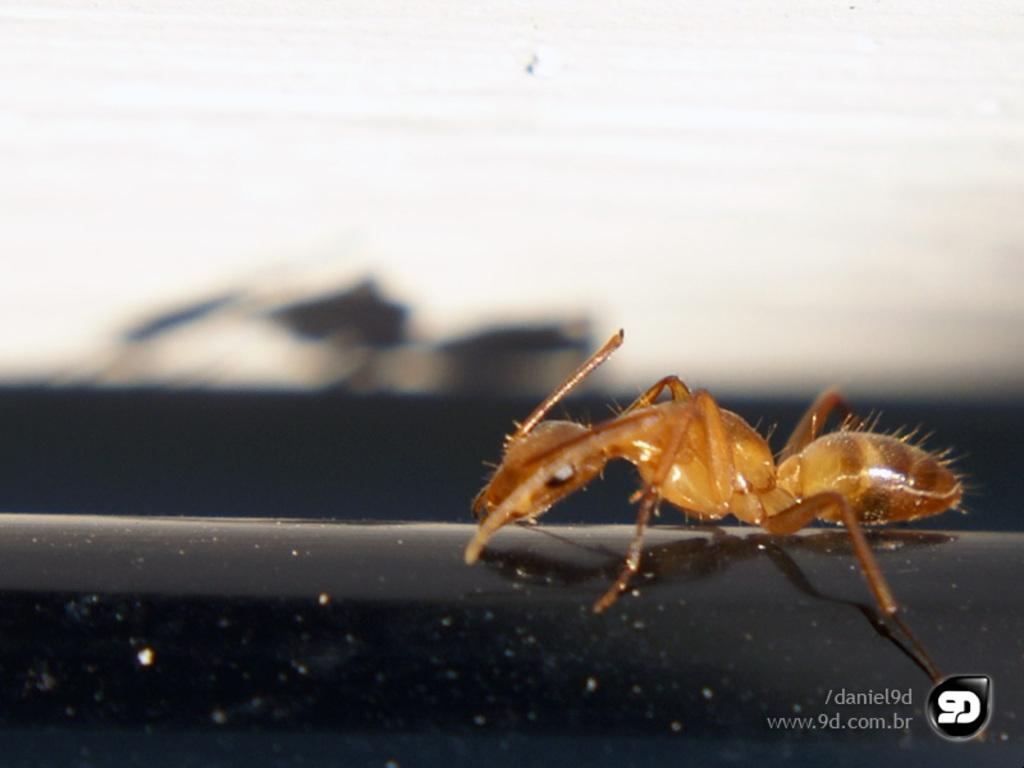What type of creature can be seen on the right side of the image? There is an insect on the right side of the image. Is there any text or symbol present in the image? Yes, there is a watermark at the right bottom of the image. What type of soda is being served in the image? There is no soda present in the image; it only features an insect and a watermark. 